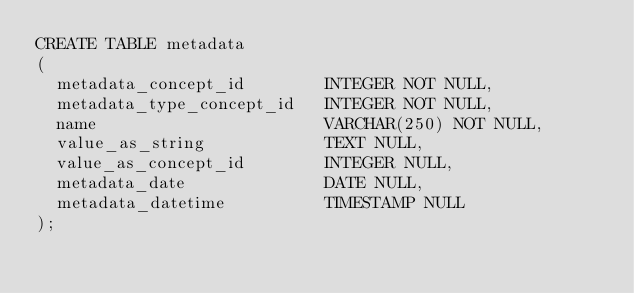Convert code to text. <code><loc_0><loc_0><loc_500><loc_500><_SQL_>CREATE TABLE metadata
(
  metadata_concept_id        INTEGER NOT NULL,
  metadata_type_concept_id   INTEGER NOT NULL,
  name                       VARCHAR(250) NOT NULL,
  value_as_string            TEXT NULL,
  value_as_concept_id        INTEGER NULL,
  metadata_date              DATE NULL,
  metadata_datetime          TIMESTAMP NULL
);
</code> 